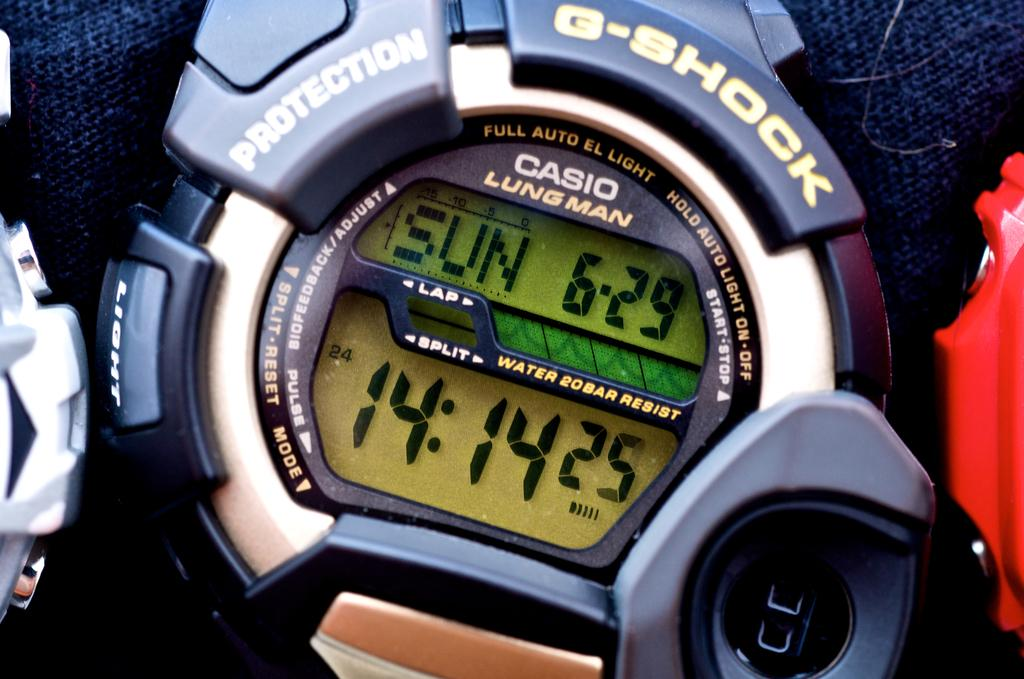What type of objects are in the image? There are three digital wrist watches in the image. What is beneath the watches? There is a cloth below the watches. What type of fruit is being used to hold the watches in the image? There is no fruit present in the image; the watches are resting on a cloth. 